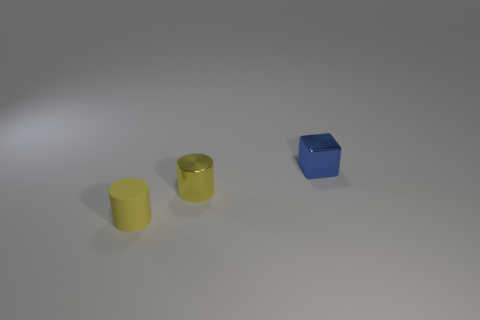What might the placement of these objects suggest about the space they are in? The placement of the objects suggests they are in a controlled, uncluttered space, likely for display or artistic purposes. The deliberate spacing and neutral background implies a focus on form and color over function, hinting that this could be a setting for product photography, an educational tool to study shapes and colors, or perhaps an art installation that emphasizes the purity of geometric forms. 